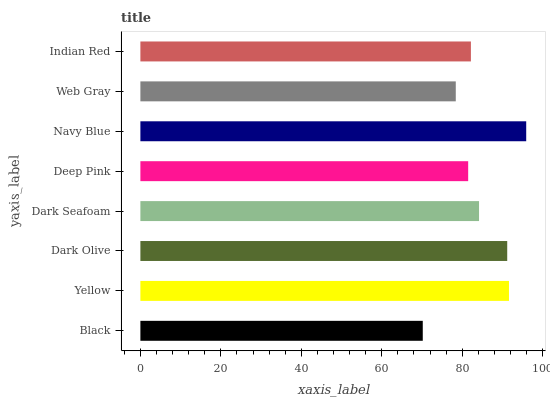Is Black the minimum?
Answer yes or no. Yes. Is Navy Blue the maximum?
Answer yes or no. Yes. Is Yellow the minimum?
Answer yes or no. No. Is Yellow the maximum?
Answer yes or no. No. Is Yellow greater than Black?
Answer yes or no. Yes. Is Black less than Yellow?
Answer yes or no. Yes. Is Black greater than Yellow?
Answer yes or no. No. Is Yellow less than Black?
Answer yes or no. No. Is Dark Seafoam the high median?
Answer yes or no. Yes. Is Indian Red the low median?
Answer yes or no. Yes. Is Deep Pink the high median?
Answer yes or no. No. Is Dark Seafoam the low median?
Answer yes or no. No. 